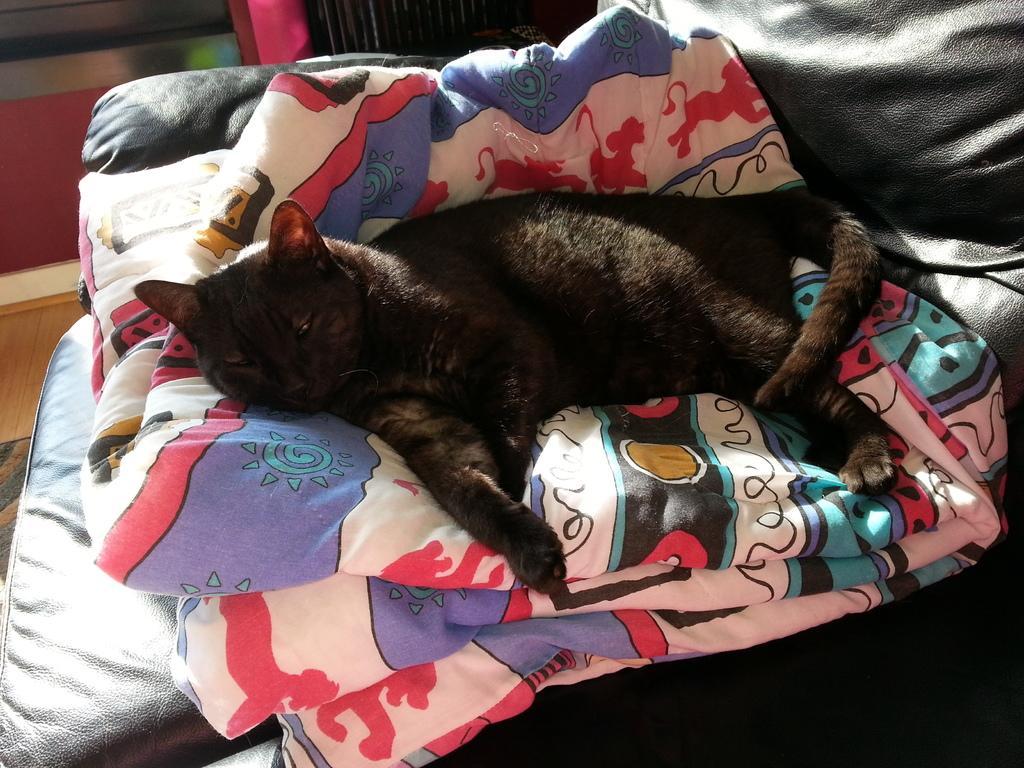How would you summarize this image in a sentence or two? In this picture there is a black color cat is sleeping on the colorful cloth which is placed on the black leather sofa. 